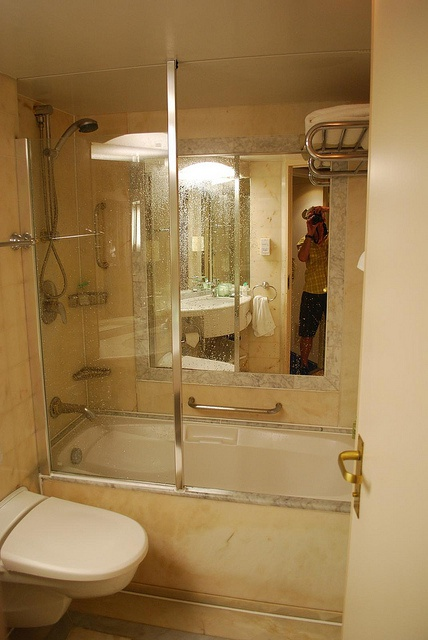Describe the objects in this image and their specific colors. I can see toilet in gray, tan, and maroon tones, people in gray, black, maroon, and olive tones, and sink in gray and tan tones in this image. 